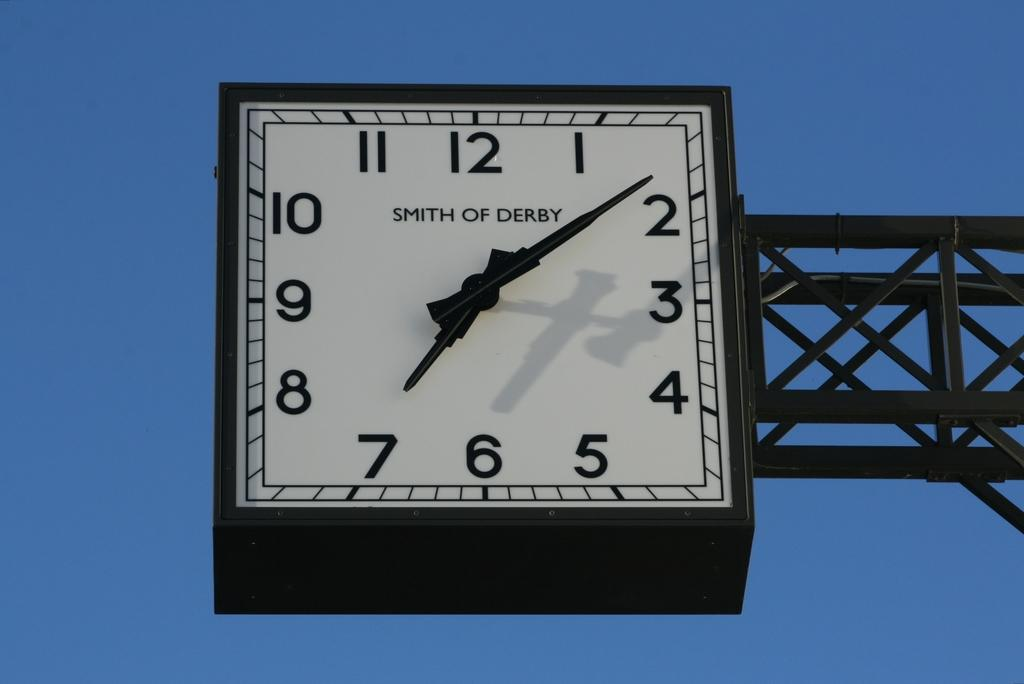<image>
Write a terse but informative summary of the picture. a clock that has the time on it which includes the number 7 